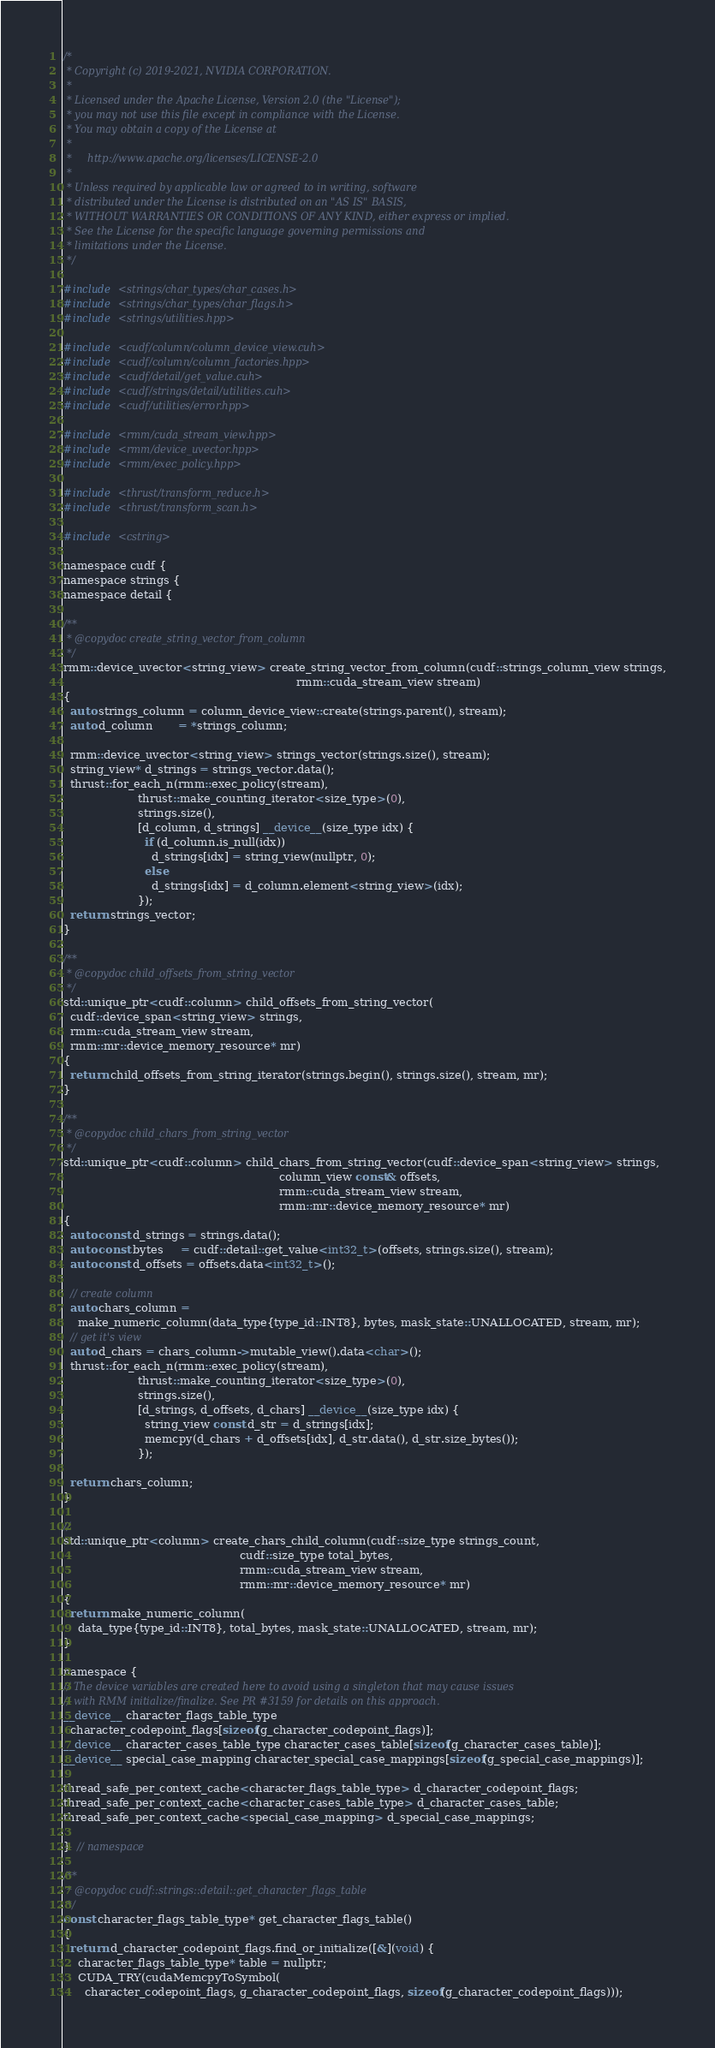Convert code to text. <code><loc_0><loc_0><loc_500><loc_500><_Cuda_>/*
 * Copyright (c) 2019-2021, NVIDIA CORPORATION.
 *
 * Licensed under the Apache License, Version 2.0 (the "License");
 * you may not use this file except in compliance with the License.
 * You may obtain a copy of the License at
 *
 *     http://www.apache.org/licenses/LICENSE-2.0
 *
 * Unless required by applicable law or agreed to in writing, software
 * distributed under the License is distributed on an "AS IS" BASIS,
 * WITHOUT WARRANTIES OR CONDITIONS OF ANY KIND, either express or implied.
 * See the License for the specific language governing permissions and
 * limitations under the License.
 */

#include <strings/char_types/char_cases.h>
#include <strings/char_types/char_flags.h>
#include <strings/utilities.hpp>

#include <cudf/column/column_device_view.cuh>
#include <cudf/column/column_factories.hpp>
#include <cudf/detail/get_value.cuh>
#include <cudf/strings/detail/utilities.cuh>
#include <cudf/utilities/error.hpp>

#include <rmm/cuda_stream_view.hpp>
#include <rmm/device_uvector.hpp>
#include <rmm/exec_policy.hpp>

#include <thrust/transform_reduce.h>
#include <thrust/transform_scan.h>

#include <cstring>

namespace cudf {
namespace strings {
namespace detail {

/**
 * @copydoc create_string_vector_from_column
 */
rmm::device_uvector<string_view> create_string_vector_from_column(cudf::strings_column_view strings,
                                                                  rmm::cuda_stream_view stream)
{
  auto strings_column = column_device_view::create(strings.parent(), stream);
  auto d_column       = *strings_column;

  rmm::device_uvector<string_view> strings_vector(strings.size(), stream);
  string_view* d_strings = strings_vector.data();
  thrust::for_each_n(rmm::exec_policy(stream),
                     thrust::make_counting_iterator<size_type>(0),
                     strings.size(),
                     [d_column, d_strings] __device__(size_type idx) {
                       if (d_column.is_null(idx))
                         d_strings[idx] = string_view(nullptr, 0);
                       else
                         d_strings[idx] = d_column.element<string_view>(idx);
                     });
  return strings_vector;
}

/**
 * @copydoc child_offsets_from_string_vector
 */
std::unique_ptr<cudf::column> child_offsets_from_string_vector(
  cudf::device_span<string_view> strings,
  rmm::cuda_stream_view stream,
  rmm::mr::device_memory_resource* mr)
{
  return child_offsets_from_string_iterator(strings.begin(), strings.size(), stream, mr);
}

/**
 * @copydoc child_chars_from_string_vector
 */
std::unique_ptr<cudf::column> child_chars_from_string_vector(cudf::device_span<string_view> strings,
                                                             column_view const& offsets,
                                                             rmm::cuda_stream_view stream,
                                                             rmm::mr::device_memory_resource* mr)
{
  auto const d_strings = strings.data();
  auto const bytes     = cudf::detail::get_value<int32_t>(offsets, strings.size(), stream);
  auto const d_offsets = offsets.data<int32_t>();

  // create column
  auto chars_column =
    make_numeric_column(data_type{type_id::INT8}, bytes, mask_state::UNALLOCATED, stream, mr);
  // get it's view
  auto d_chars = chars_column->mutable_view().data<char>();
  thrust::for_each_n(rmm::exec_policy(stream),
                     thrust::make_counting_iterator<size_type>(0),
                     strings.size(),
                     [d_strings, d_offsets, d_chars] __device__(size_type idx) {
                       string_view const d_str = d_strings[idx];
                       memcpy(d_chars + d_offsets[idx], d_str.data(), d_str.size_bytes());
                     });

  return chars_column;
}

//
std::unique_ptr<column> create_chars_child_column(cudf::size_type strings_count,
                                                  cudf::size_type total_bytes,
                                                  rmm::cuda_stream_view stream,
                                                  rmm::mr::device_memory_resource* mr)
{
  return make_numeric_column(
    data_type{type_id::INT8}, total_bytes, mask_state::UNALLOCATED, stream, mr);
}

namespace {
// The device variables are created here to avoid using a singleton that may cause issues
// with RMM initialize/finalize. See PR #3159 for details on this approach.
__device__ character_flags_table_type
  character_codepoint_flags[sizeof(g_character_codepoint_flags)];
__device__ character_cases_table_type character_cases_table[sizeof(g_character_cases_table)];
__device__ special_case_mapping character_special_case_mappings[sizeof(g_special_case_mappings)];

thread_safe_per_context_cache<character_flags_table_type> d_character_codepoint_flags;
thread_safe_per_context_cache<character_cases_table_type> d_character_cases_table;
thread_safe_per_context_cache<special_case_mapping> d_special_case_mappings;

}  // namespace

/**
 * @copydoc cudf::strings::detail::get_character_flags_table
 */
const character_flags_table_type* get_character_flags_table()
{
  return d_character_codepoint_flags.find_or_initialize([&](void) {
    character_flags_table_type* table = nullptr;
    CUDA_TRY(cudaMemcpyToSymbol(
      character_codepoint_flags, g_character_codepoint_flags, sizeof(g_character_codepoint_flags)));</code> 